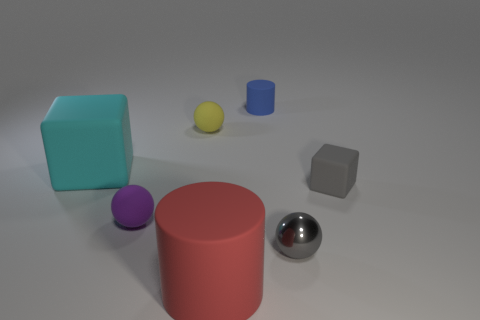Imagine these objects are part of a learning exercise; what could be the purpose or lesson behind their arrangement? This assembly could serve as a learning exercise in visual composition, color theory, or the properties of light and materials. For example, students might be tasked with understanding how light interacts with different surfaces, or how the positioning of colored objects can affect visual perception and evoke certain emotions or ideas. 